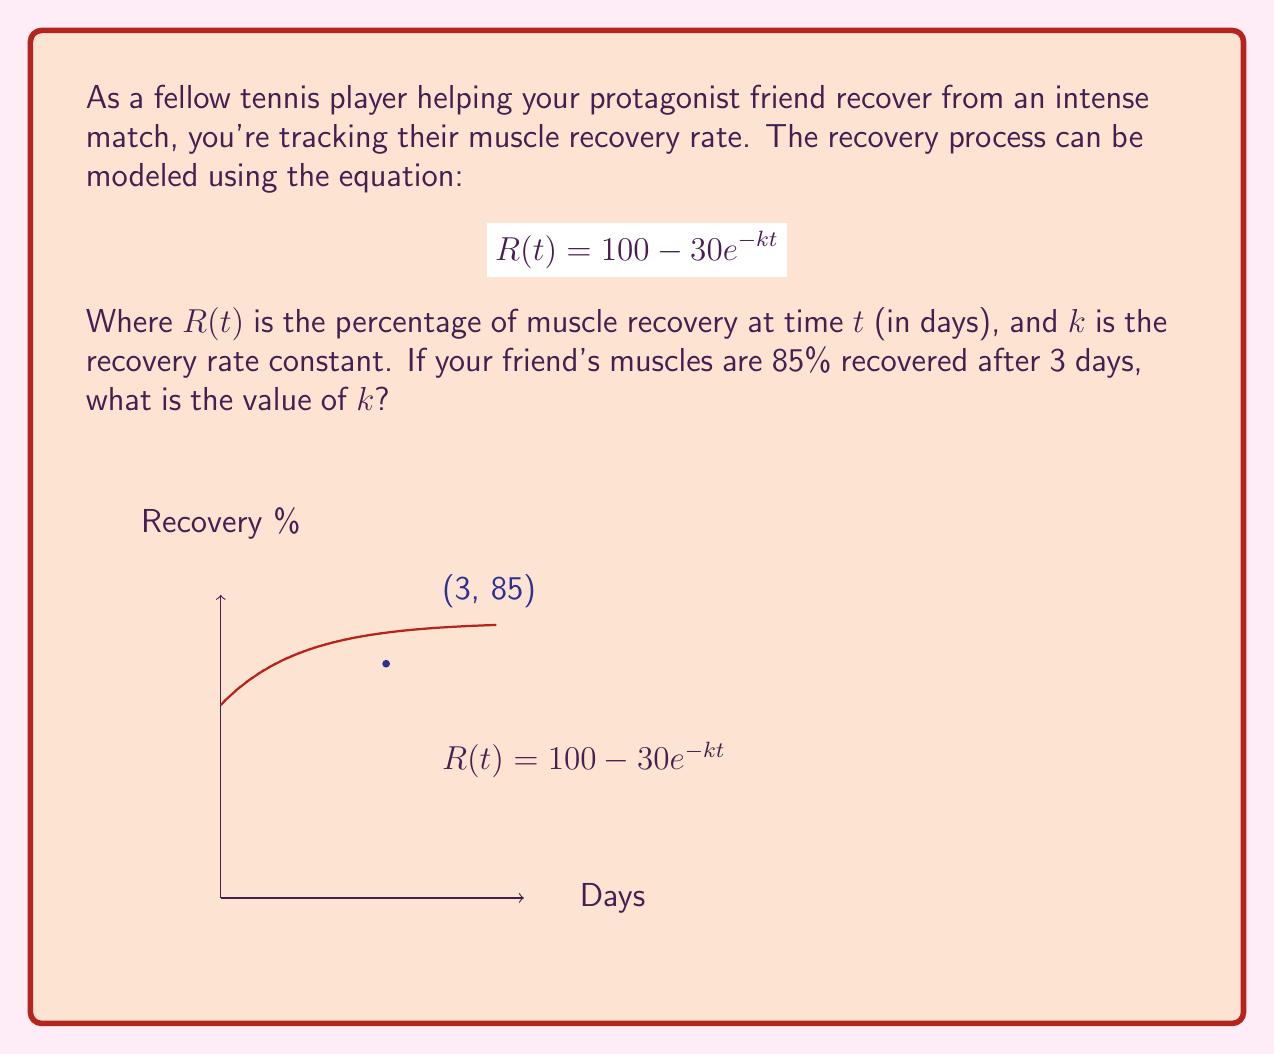Can you answer this question? Let's approach this step-by-step:

1) We're given the equation $R(t) = 100 - 30e^{-kt}$

2) We know that after 3 days (t = 3), the recovery is 85% (R(3) = 85)

3) Let's substitute these values into the equation:

   $85 = 100 - 30e^{-k(3)}$

4) Subtract both sides from 100:

   $15 = 30e^{-3k}$

5) Divide both sides by 30:

   $0.5 = e^{-3k}$

6) Take the natural log of both sides:

   $\ln(0.5) = -3k$

7) We know that $\ln(0.5) = -0.693$ (approximately)

8) So we have:

   $-0.693 = -3k$

9) Divide both sides by -3:

   $0.231 = k$

Therefore, the recovery rate constant $k$ is approximately 0.231.
Answer: $k \approx 0.231$ 